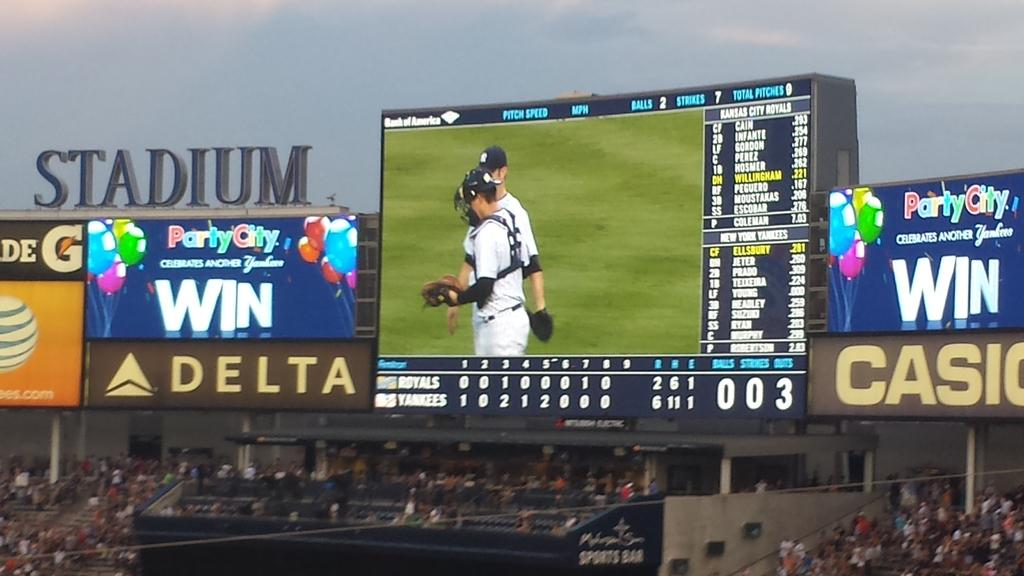<image>
Offer a succinct explanation of the picture presented. A baseball game has a packed stadium and an ad for Delta and Casio. 